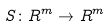Convert formula to latex. <formula><loc_0><loc_0><loc_500><loc_500>S \colon R ^ { m } \rightarrow R ^ { m }</formula> 